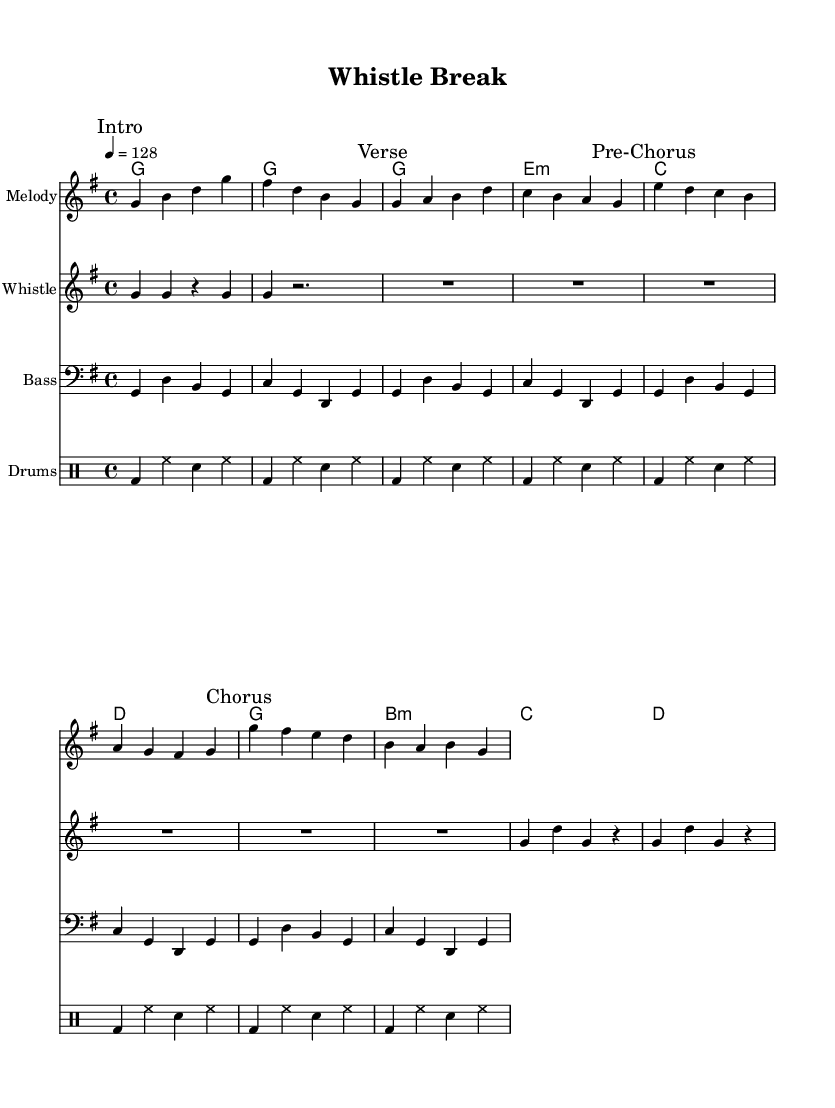What is the key signature of this music? The key signature is G major, which has one sharp (F#).
Answer: G major What is the time signature of this music? The time signature is 4/4, meaning there are four beats per measure and the quarter note gets one beat.
Answer: 4/4 What is the tempo marking for this piece? The tempo marking is 128 beats per minute, indicating how fast the piece should be played.
Answer: 128 How many measures does the whistle section contain? The whistle section has a total of 4 measures, as visible by counting the bars in the whistle staff.
Answer: 4 What is the main rhythmic figure used in the drum pattern? The main rhythmic figure features a consistent pattern of bass drum and snare hits, typical in K-Pop songs to drive the beat.
Answer: Bass and snare Which section follows the verse in the structure? The pre-chorus follows the verse, as indicated by the markings in the melody section.
Answer: Pre-Chorus What unique element does this K-Pop track include that is reminiscent of referee whistles? The track includes a segment marked "Whistle" where a series of G notes are used, similar to a referee's whistle sound.
Answer: Whistle 